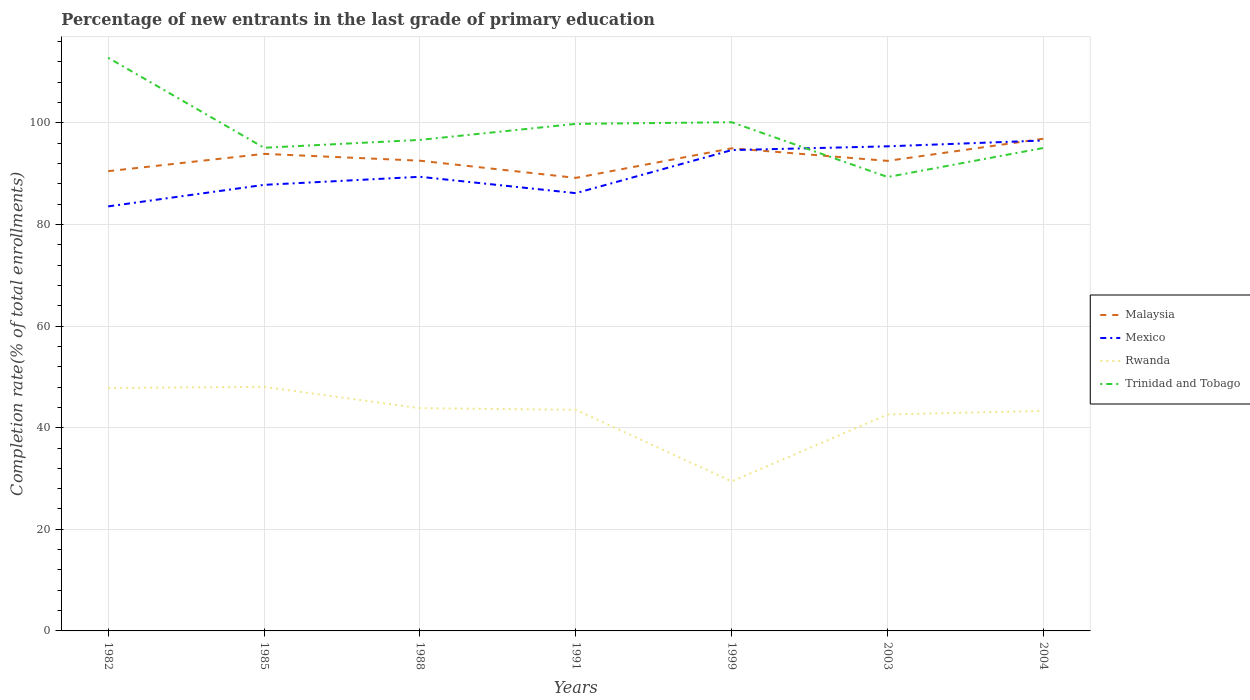How many different coloured lines are there?
Your answer should be very brief. 4. Is the number of lines equal to the number of legend labels?
Your answer should be compact. Yes. Across all years, what is the maximum percentage of new entrants in Trinidad and Tobago?
Your answer should be very brief. 89.33. In which year was the percentage of new entrants in Mexico maximum?
Your answer should be compact. 1982. What is the total percentage of new entrants in Trinidad and Tobago in the graph?
Keep it short and to the point. -1.55. What is the difference between the highest and the second highest percentage of new entrants in Mexico?
Provide a succinct answer. 12.97. How many lines are there?
Your response must be concise. 4. How many years are there in the graph?
Your response must be concise. 7. What is the difference between two consecutive major ticks on the Y-axis?
Your response must be concise. 20. How many legend labels are there?
Your response must be concise. 4. How are the legend labels stacked?
Your answer should be compact. Vertical. What is the title of the graph?
Keep it short and to the point. Percentage of new entrants in the last grade of primary education. What is the label or title of the Y-axis?
Your answer should be compact. Completion rate(% of total enrollments). What is the Completion rate(% of total enrollments) of Malaysia in 1982?
Your answer should be compact. 90.48. What is the Completion rate(% of total enrollments) of Mexico in 1982?
Your response must be concise. 83.55. What is the Completion rate(% of total enrollments) of Rwanda in 1982?
Your response must be concise. 47.82. What is the Completion rate(% of total enrollments) in Trinidad and Tobago in 1982?
Make the answer very short. 112.8. What is the Completion rate(% of total enrollments) in Malaysia in 1985?
Keep it short and to the point. 93.89. What is the Completion rate(% of total enrollments) in Mexico in 1985?
Provide a short and direct response. 87.79. What is the Completion rate(% of total enrollments) in Rwanda in 1985?
Provide a short and direct response. 48.02. What is the Completion rate(% of total enrollments) in Trinidad and Tobago in 1985?
Your answer should be compact. 95.09. What is the Completion rate(% of total enrollments) in Malaysia in 1988?
Your answer should be compact. 92.54. What is the Completion rate(% of total enrollments) in Mexico in 1988?
Provide a short and direct response. 89.37. What is the Completion rate(% of total enrollments) in Rwanda in 1988?
Your answer should be very brief. 43.84. What is the Completion rate(% of total enrollments) in Trinidad and Tobago in 1988?
Ensure brevity in your answer.  96.64. What is the Completion rate(% of total enrollments) in Malaysia in 1991?
Offer a terse response. 89.16. What is the Completion rate(% of total enrollments) of Mexico in 1991?
Give a very brief answer. 86.16. What is the Completion rate(% of total enrollments) of Rwanda in 1991?
Make the answer very short. 43.52. What is the Completion rate(% of total enrollments) of Trinidad and Tobago in 1991?
Offer a terse response. 99.79. What is the Completion rate(% of total enrollments) in Malaysia in 1999?
Your response must be concise. 94.98. What is the Completion rate(% of total enrollments) of Mexico in 1999?
Offer a terse response. 94.63. What is the Completion rate(% of total enrollments) in Rwanda in 1999?
Provide a succinct answer. 29.43. What is the Completion rate(% of total enrollments) of Trinidad and Tobago in 1999?
Offer a very short reply. 100.11. What is the Completion rate(% of total enrollments) of Malaysia in 2003?
Keep it short and to the point. 92.51. What is the Completion rate(% of total enrollments) of Mexico in 2003?
Keep it short and to the point. 95.37. What is the Completion rate(% of total enrollments) of Rwanda in 2003?
Keep it short and to the point. 42.6. What is the Completion rate(% of total enrollments) in Trinidad and Tobago in 2003?
Make the answer very short. 89.33. What is the Completion rate(% of total enrollments) in Malaysia in 2004?
Provide a short and direct response. 96.87. What is the Completion rate(% of total enrollments) in Mexico in 2004?
Offer a very short reply. 96.51. What is the Completion rate(% of total enrollments) of Rwanda in 2004?
Your response must be concise. 43.31. What is the Completion rate(% of total enrollments) in Trinidad and Tobago in 2004?
Give a very brief answer. 95.05. Across all years, what is the maximum Completion rate(% of total enrollments) in Malaysia?
Your response must be concise. 96.87. Across all years, what is the maximum Completion rate(% of total enrollments) of Mexico?
Your answer should be compact. 96.51. Across all years, what is the maximum Completion rate(% of total enrollments) in Rwanda?
Your answer should be compact. 48.02. Across all years, what is the maximum Completion rate(% of total enrollments) of Trinidad and Tobago?
Your answer should be compact. 112.8. Across all years, what is the minimum Completion rate(% of total enrollments) of Malaysia?
Give a very brief answer. 89.16. Across all years, what is the minimum Completion rate(% of total enrollments) of Mexico?
Offer a terse response. 83.55. Across all years, what is the minimum Completion rate(% of total enrollments) in Rwanda?
Your answer should be compact. 29.43. Across all years, what is the minimum Completion rate(% of total enrollments) in Trinidad and Tobago?
Provide a succinct answer. 89.33. What is the total Completion rate(% of total enrollments) in Malaysia in the graph?
Your response must be concise. 650.44. What is the total Completion rate(% of total enrollments) of Mexico in the graph?
Provide a short and direct response. 633.38. What is the total Completion rate(% of total enrollments) of Rwanda in the graph?
Your response must be concise. 298.53. What is the total Completion rate(% of total enrollments) in Trinidad and Tobago in the graph?
Ensure brevity in your answer.  688.81. What is the difference between the Completion rate(% of total enrollments) of Malaysia in 1982 and that in 1985?
Your answer should be compact. -3.41. What is the difference between the Completion rate(% of total enrollments) in Mexico in 1982 and that in 1985?
Your answer should be very brief. -4.24. What is the difference between the Completion rate(% of total enrollments) in Rwanda in 1982 and that in 1985?
Provide a succinct answer. -0.2. What is the difference between the Completion rate(% of total enrollments) in Trinidad and Tobago in 1982 and that in 1985?
Offer a terse response. 17.72. What is the difference between the Completion rate(% of total enrollments) of Malaysia in 1982 and that in 1988?
Give a very brief answer. -2.06. What is the difference between the Completion rate(% of total enrollments) in Mexico in 1982 and that in 1988?
Offer a terse response. -5.83. What is the difference between the Completion rate(% of total enrollments) in Rwanda in 1982 and that in 1988?
Make the answer very short. 3.98. What is the difference between the Completion rate(% of total enrollments) of Trinidad and Tobago in 1982 and that in 1988?
Your answer should be compact. 16.16. What is the difference between the Completion rate(% of total enrollments) in Malaysia in 1982 and that in 1991?
Keep it short and to the point. 1.32. What is the difference between the Completion rate(% of total enrollments) of Mexico in 1982 and that in 1991?
Provide a short and direct response. -2.61. What is the difference between the Completion rate(% of total enrollments) in Rwanda in 1982 and that in 1991?
Give a very brief answer. 4.3. What is the difference between the Completion rate(% of total enrollments) of Trinidad and Tobago in 1982 and that in 1991?
Provide a short and direct response. 13.01. What is the difference between the Completion rate(% of total enrollments) of Malaysia in 1982 and that in 1999?
Give a very brief answer. -4.5. What is the difference between the Completion rate(% of total enrollments) of Mexico in 1982 and that in 1999?
Provide a succinct answer. -11.08. What is the difference between the Completion rate(% of total enrollments) of Rwanda in 1982 and that in 1999?
Keep it short and to the point. 18.39. What is the difference between the Completion rate(% of total enrollments) of Trinidad and Tobago in 1982 and that in 1999?
Keep it short and to the point. 12.69. What is the difference between the Completion rate(% of total enrollments) of Malaysia in 1982 and that in 2003?
Make the answer very short. -2.02. What is the difference between the Completion rate(% of total enrollments) in Mexico in 1982 and that in 2003?
Ensure brevity in your answer.  -11.82. What is the difference between the Completion rate(% of total enrollments) in Rwanda in 1982 and that in 2003?
Your response must be concise. 5.22. What is the difference between the Completion rate(% of total enrollments) of Trinidad and Tobago in 1982 and that in 2003?
Make the answer very short. 23.47. What is the difference between the Completion rate(% of total enrollments) in Malaysia in 1982 and that in 2004?
Keep it short and to the point. -6.39. What is the difference between the Completion rate(% of total enrollments) in Mexico in 1982 and that in 2004?
Your answer should be very brief. -12.97. What is the difference between the Completion rate(% of total enrollments) of Rwanda in 1982 and that in 2004?
Provide a short and direct response. 4.51. What is the difference between the Completion rate(% of total enrollments) in Trinidad and Tobago in 1982 and that in 2004?
Your answer should be compact. 17.76. What is the difference between the Completion rate(% of total enrollments) of Malaysia in 1985 and that in 1988?
Offer a terse response. 1.34. What is the difference between the Completion rate(% of total enrollments) in Mexico in 1985 and that in 1988?
Ensure brevity in your answer.  -1.59. What is the difference between the Completion rate(% of total enrollments) in Rwanda in 1985 and that in 1988?
Give a very brief answer. 4.19. What is the difference between the Completion rate(% of total enrollments) in Trinidad and Tobago in 1985 and that in 1988?
Your answer should be very brief. -1.55. What is the difference between the Completion rate(% of total enrollments) in Malaysia in 1985 and that in 1991?
Offer a very short reply. 4.73. What is the difference between the Completion rate(% of total enrollments) in Mexico in 1985 and that in 1991?
Your answer should be very brief. 1.63. What is the difference between the Completion rate(% of total enrollments) of Rwanda in 1985 and that in 1991?
Keep it short and to the point. 4.5. What is the difference between the Completion rate(% of total enrollments) of Trinidad and Tobago in 1985 and that in 1991?
Provide a short and direct response. -4.7. What is the difference between the Completion rate(% of total enrollments) in Malaysia in 1985 and that in 1999?
Offer a very short reply. -1.09. What is the difference between the Completion rate(% of total enrollments) of Mexico in 1985 and that in 1999?
Keep it short and to the point. -6.84. What is the difference between the Completion rate(% of total enrollments) of Rwanda in 1985 and that in 1999?
Keep it short and to the point. 18.6. What is the difference between the Completion rate(% of total enrollments) in Trinidad and Tobago in 1985 and that in 1999?
Ensure brevity in your answer.  -5.03. What is the difference between the Completion rate(% of total enrollments) of Malaysia in 1985 and that in 2003?
Provide a short and direct response. 1.38. What is the difference between the Completion rate(% of total enrollments) in Mexico in 1985 and that in 2003?
Your response must be concise. -7.58. What is the difference between the Completion rate(% of total enrollments) in Rwanda in 1985 and that in 2003?
Your answer should be very brief. 5.43. What is the difference between the Completion rate(% of total enrollments) in Trinidad and Tobago in 1985 and that in 2003?
Offer a terse response. 5.75. What is the difference between the Completion rate(% of total enrollments) of Malaysia in 1985 and that in 2004?
Your answer should be very brief. -2.98. What is the difference between the Completion rate(% of total enrollments) in Mexico in 1985 and that in 2004?
Offer a terse response. -8.73. What is the difference between the Completion rate(% of total enrollments) in Rwanda in 1985 and that in 2004?
Your answer should be compact. 4.72. What is the difference between the Completion rate(% of total enrollments) of Trinidad and Tobago in 1985 and that in 2004?
Your answer should be compact. 0.04. What is the difference between the Completion rate(% of total enrollments) in Malaysia in 1988 and that in 1991?
Provide a short and direct response. 3.38. What is the difference between the Completion rate(% of total enrollments) of Mexico in 1988 and that in 1991?
Your response must be concise. 3.22. What is the difference between the Completion rate(% of total enrollments) of Rwanda in 1988 and that in 1991?
Give a very brief answer. 0.32. What is the difference between the Completion rate(% of total enrollments) of Trinidad and Tobago in 1988 and that in 1991?
Offer a very short reply. -3.15. What is the difference between the Completion rate(% of total enrollments) of Malaysia in 1988 and that in 1999?
Your answer should be very brief. -2.44. What is the difference between the Completion rate(% of total enrollments) in Mexico in 1988 and that in 1999?
Give a very brief answer. -5.25. What is the difference between the Completion rate(% of total enrollments) of Rwanda in 1988 and that in 1999?
Provide a short and direct response. 14.41. What is the difference between the Completion rate(% of total enrollments) of Trinidad and Tobago in 1988 and that in 1999?
Your answer should be very brief. -3.48. What is the difference between the Completion rate(% of total enrollments) in Malaysia in 1988 and that in 2003?
Your answer should be compact. 0.04. What is the difference between the Completion rate(% of total enrollments) in Mexico in 1988 and that in 2003?
Provide a short and direct response. -6. What is the difference between the Completion rate(% of total enrollments) in Rwanda in 1988 and that in 2003?
Your answer should be very brief. 1.24. What is the difference between the Completion rate(% of total enrollments) of Trinidad and Tobago in 1988 and that in 2003?
Provide a short and direct response. 7.31. What is the difference between the Completion rate(% of total enrollments) in Malaysia in 1988 and that in 2004?
Provide a succinct answer. -4.33. What is the difference between the Completion rate(% of total enrollments) of Mexico in 1988 and that in 2004?
Your response must be concise. -7.14. What is the difference between the Completion rate(% of total enrollments) in Rwanda in 1988 and that in 2004?
Keep it short and to the point. 0.53. What is the difference between the Completion rate(% of total enrollments) of Trinidad and Tobago in 1988 and that in 2004?
Provide a succinct answer. 1.59. What is the difference between the Completion rate(% of total enrollments) of Malaysia in 1991 and that in 1999?
Offer a very short reply. -5.82. What is the difference between the Completion rate(% of total enrollments) in Mexico in 1991 and that in 1999?
Offer a terse response. -8.47. What is the difference between the Completion rate(% of total enrollments) of Rwanda in 1991 and that in 1999?
Your answer should be very brief. 14.09. What is the difference between the Completion rate(% of total enrollments) of Trinidad and Tobago in 1991 and that in 1999?
Your answer should be compact. -0.32. What is the difference between the Completion rate(% of total enrollments) in Malaysia in 1991 and that in 2003?
Your response must be concise. -3.34. What is the difference between the Completion rate(% of total enrollments) in Mexico in 1991 and that in 2003?
Keep it short and to the point. -9.22. What is the difference between the Completion rate(% of total enrollments) of Rwanda in 1991 and that in 2003?
Keep it short and to the point. 0.92. What is the difference between the Completion rate(% of total enrollments) of Trinidad and Tobago in 1991 and that in 2003?
Your response must be concise. 10.46. What is the difference between the Completion rate(% of total enrollments) in Malaysia in 1991 and that in 2004?
Make the answer very short. -7.71. What is the difference between the Completion rate(% of total enrollments) in Mexico in 1991 and that in 2004?
Ensure brevity in your answer.  -10.36. What is the difference between the Completion rate(% of total enrollments) in Rwanda in 1991 and that in 2004?
Make the answer very short. 0.21. What is the difference between the Completion rate(% of total enrollments) of Trinidad and Tobago in 1991 and that in 2004?
Your response must be concise. 4.74. What is the difference between the Completion rate(% of total enrollments) of Malaysia in 1999 and that in 2003?
Keep it short and to the point. 2.47. What is the difference between the Completion rate(% of total enrollments) in Mexico in 1999 and that in 2003?
Your answer should be very brief. -0.75. What is the difference between the Completion rate(% of total enrollments) of Rwanda in 1999 and that in 2003?
Provide a succinct answer. -13.17. What is the difference between the Completion rate(% of total enrollments) of Trinidad and Tobago in 1999 and that in 2003?
Your response must be concise. 10.78. What is the difference between the Completion rate(% of total enrollments) in Malaysia in 1999 and that in 2004?
Make the answer very short. -1.89. What is the difference between the Completion rate(% of total enrollments) of Mexico in 1999 and that in 2004?
Offer a very short reply. -1.89. What is the difference between the Completion rate(% of total enrollments) of Rwanda in 1999 and that in 2004?
Your answer should be very brief. -13.88. What is the difference between the Completion rate(% of total enrollments) in Trinidad and Tobago in 1999 and that in 2004?
Ensure brevity in your answer.  5.07. What is the difference between the Completion rate(% of total enrollments) of Malaysia in 2003 and that in 2004?
Provide a short and direct response. -4.36. What is the difference between the Completion rate(% of total enrollments) of Mexico in 2003 and that in 2004?
Keep it short and to the point. -1.14. What is the difference between the Completion rate(% of total enrollments) of Rwanda in 2003 and that in 2004?
Your answer should be very brief. -0.71. What is the difference between the Completion rate(% of total enrollments) of Trinidad and Tobago in 2003 and that in 2004?
Your answer should be very brief. -5.71. What is the difference between the Completion rate(% of total enrollments) of Malaysia in 1982 and the Completion rate(% of total enrollments) of Mexico in 1985?
Offer a terse response. 2.69. What is the difference between the Completion rate(% of total enrollments) in Malaysia in 1982 and the Completion rate(% of total enrollments) in Rwanda in 1985?
Your answer should be very brief. 42.46. What is the difference between the Completion rate(% of total enrollments) of Malaysia in 1982 and the Completion rate(% of total enrollments) of Trinidad and Tobago in 1985?
Your answer should be compact. -4.6. What is the difference between the Completion rate(% of total enrollments) in Mexico in 1982 and the Completion rate(% of total enrollments) in Rwanda in 1985?
Provide a succinct answer. 35.53. What is the difference between the Completion rate(% of total enrollments) of Mexico in 1982 and the Completion rate(% of total enrollments) of Trinidad and Tobago in 1985?
Give a very brief answer. -11.54. What is the difference between the Completion rate(% of total enrollments) in Rwanda in 1982 and the Completion rate(% of total enrollments) in Trinidad and Tobago in 1985?
Your answer should be compact. -47.27. What is the difference between the Completion rate(% of total enrollments) in Malaysia in 1982 and the Completion rate(% of total enrollments) in Mexico in 1988?
Offer a very short reply. 1.11. What is the difference between the Completion rate(% of total enrollments) in Malaysia in 1982 and the Completion rate(% of total enrollments) in Rwanda in 1988?
Make the answer very short. 46.64. What is the difference between the Completion rate(% of total enrollments) of Malaysia in 1982 and the Completion rate(% of total enrollments) of Trinidad and Tobago in 1988?
Ensure brevity in your answer.  -6.16. What is the difference between the Completion rate(% of total enrollments) in Mexico in 1982 and the Completion rate(% of total enrollments) in Rwanda in 1988?
Give a very brief answer. 39.71. What is the difference between the Completion rate(% of total enrollments) of Mexico in 1982 and the Completion rate(% of total enrollments) of Trinidad and Tobago in 1988?
Give a very brief answer. -13.09. What is the difference between the Completion rate(% of total enrollments) of Rwanda in 1982 and the Completion rate(% of total enrollments) of Trinidad and Tobago in 1988?
Provide a short and direct response. -48.82. What is the difference between the Completion rate(% of total enrollments) of Malaysia in 1982 and the Completion rate(% of total enrollments) of Mexico in 1991?
Ensure brevity in your answer.  4.33. What is the difference between the Completion rate(% of total enrollments) in Malaysia in 1982 and the Completion rate(% of total enrollments) in Rwanda in 1991?
Provide a succinct answer. 46.96. What is the difference between the Completion rate(% of total enrollments) of Malaysia in 1982 and the Completion rate(% of total enrollments) of Trinidad and Tobago in 1991?
Your answer should be very brief. -9.31. What is the difference between the Completion rate(% of total enrollments) in Mexico in 1982 and the Completion rate(% of total enrollments) in Rwanda in 1991?
Your answer should be compact. 40.03. What is the difference between the Completion rate(% of total enrollments) in Mexico in 1982 and the Completion rate(% of total enrollments) in Trinidad and Tobago in 1991?
Your response must be concise. -16.24. What is the difference between the Completion rate(% of total enrollments) of Rwanda in 1982 and the Completion rate(% of total enrollments) of Trinidad and Tobago in 1991?
Make the answer very short. -51.97. What is the difference between the Completion rate(% of total enrollments) in Malaysia in 1982 and the Completion rate(% of total enrollments) in Mexico in 1999?
Make the answer very short. -4.15. What is the difference between the Completion rate(% of total enrollments) in Malaysia in 1982 and the Completion rate(% of total enrollments) in Rwanda in 1999?
Offer a very short reply. 61.06. What is the difference between the Completion rate(% of total enrollments) in Malaysia in 1982 and the Completion rate(% of total enrollments) in Trinidad and Tobago in 1999?
Your response must be concise. -9.63. What is the difference between the Completion rate(% of total enrollments) of Mexico in 1982 and the Completion rate(% of total enrollments) of Rwanda in 1999?
Your answer should be very brief. 54.12. What is the difference between the Completion rate(% of total enrollments) of Mexico in 1982 and the Completion rate(% of total enrollments) of Trinidad and Tobago in 1999?
Make the answer very short. -16.56. What is the difference between the Completion rate(% of total enrollments) in Rwanda in 1982 and the Completion rate(% of total enrollments) in Trinidad and Tobago in 1999?
Make the answer very short. -52.29. What is the difference between the Completion rate(% of total enrollments) in Malaysia in 1982 and the Completion rate(% of total enrollments) in Mexico in 2003?
Your response must be concise. -4.89. What is the difference between the Completion rate(% of total enrollments) of Malaysia in 1982 and the Completion rate(% of total enrollments) of Rwanda in 2003?
Keep it short and to the point. 47.89. What is the difference between the Completion rate(% of total enrollments) in Malaysia in 1982 and the Completion rate(% of total enrollments) in Trinidad and Tobago in 2003?
Keep it short and to the point. 1.15. What is the difference between the Completion rate(% of total enrollments) in Mexico in 1982 and the Completion rate(% of total enrollments) in Rwanda in 2003?
Offer a terse response. 40.95. What is the difference between the Completion rate(% of total enrollments) in Mexico in 1982 and the Completion rate(% of total enrollments) in Trinidad and Tobago in 2003?
Offer a terse response. -5.78. What is the difference between the Completion rate(% of total enrollments) of Rwanda in 1982 and the Completion rate(% of total enrollments) of Trinidad and Tobago in 2003?
Ensure brevity in your answer.  -41.51. What is the difference between the Completion rate(% of total enrollments) of Malaysia in 1982 and the Completion rate(% of total enrollments) of Mexico in 2004?
Ensure brevity in your answer.  -6.03. What is the difference between the Completion rate(% of total enrollments) of Malaysia in 1982 and the Completion rate(% of total enrollments) of Rwanda in 2004?
Offer a terse response. 47.17. What is the difference between the Completion rate(% of total enrollments) in Malaysia in 1982 and the Completion rate(% of total enrollments) in Trinidad and Tobago in 2004?
Your answer should be very brief. -4.56. What is the difference between the Completion rate(% of total enrollments) in Mexico in 1982 and the Completion rate(% of total enrollments) in Rwanda in 2004?
Ensure brevity in your answer.  40.24. What is the difference between the Completion rate(% of total enrollments) of Mexico in 1982 and the Completion rate(% of total enrollments) of Trinidad and Tobago in 2004?
Provide a short and direct response. -11.5. What is the difference between the Completion rate(% of total enrollments) of Rwanda in 1982 and the Completion rate(% of total enrollments) of Trinidad and Tobago in 2004?
Ensure brevity in your answer.  -47.23. What is the difference between the Completion rate(% of total enrollments) in Malaysia in 1985 and the Completion rate(% of total enrollments) in Mexico in 1988?
Ensure brevity in your answer.  4.51. What is the difference between the Completion rate(% of total enrollments) of Malaysia in 1985 and the Completion rate(% of total enrollments) of Rwanda in 1988?
Your answer should be very brief. 50.05. What is the difference between the Completion rate(% of total enrollments) of Malaysia in 1985 and the Completion rate(% of total enrollments) of Trinidad and Tobago in 1988?
Offer a terse response. -2.75. What is the difference between the Completion rate(% of total enrollments) of Mexico in 1985 and the Completion rate(% of total enrollments) of Rwanda in 1988?
Ensure brevity in your answer.  43.95. What is the difference between the Completion rate(% of total enrollments) of Mexico in 1985 and the Completion rate(% of total enrollments) of Trinidad and Tobago in 1988?
Make the answer very short. -8.85. What is the difference between the Completion rate(% of total enrollments) in Rwanda in 1985 and the Completion rate(% of total enrollments) in Trinidad and Tobago in 1988?
Offer a very short reply. -48.61. What is the difference between the Completion rate(% of total enrollments) of Malaysia in 1985 and the Completion rate(% of total enrollments) of Mexico in 1991?
Provide a short and direct response. 7.73. What is the difference between the Completion rate(% of total enrollments) of Malaysia in 1985 and the Completion rate(% of total enrollments) of Rwanda in 1991?
Your answer should be very brief. 50.37. What is the difference between the Completion rate(% of total enrollments) of Malaysia in 1985 and the Completion rate(% of total enrollments) of Trinidad and Tobago in 1991?
Give a very brief answer. -5.9. What is the difference between the Completion rate(% of total enrollments) of Mexico in 1985 and the Completion rate(% of total enrollments) of Rwanda in 1991?
Your answer should be compact. 44.27. What is the difference between the Completion rate(% of total enrollments) in Mexico in 1985 and the Completion rate(% of total enrollments) in Trinidad and Tobago in 1991?
Make the answer very short. -12. What is the difference between the Completion rate(% of total enrollments) of Rwanda in 1985 and the Completion rate(% of total enrollments) of Trinidad and Tobago in 1991?
Offer a very short reply. -51.77. What is the difference between the Completion rate(% of total enrollments) in Malaysia in 1985 and the Completion rate(% of total enrollments) in Mexico in 1999?
Your answer should be very brief. -0.74. What is the difference between the Completion rate(% of total enrollments) in Malaysia in 1985 and the Completion rate(% of total enrollments) in Rwanda in 1999?
Ensure brevity in your answer.  64.46. What is the difference between the Completion rate(% of total enrollments) of Malaysia in 1985 and the Completion rate(% of total enrollments) of Trinidad and Tobago in 1999?
Your response must be concise. -6.23. What is the difference between the Completion rate(% of total enrollments) in Mexico in 1985 and the Completion rate(% of total enrollments) in Rwanda in 1999?
Offer a very short reply. 58.36. What is the difference between the Completion rate(% of total enrollments) in Mexico in 1985 and the Completion rate(% of total enrollments) in Trinidad and Tobago in 1999?
Provide a succinct answer. -12.33. What is the difference between the Completion rate(% of total enrollments) in Rwanda in 1985 and the Completion rate(% of total enrollments) in Trinidad and Tobago in 1999?
Provide a succinct answer. -52.09. What is the difference between the Completion rate(% of total enrollments) in Malaysia in 1985 and the Completion rate(% of total enrollments) in Mexico in 2003?
Make the answer very short. -1.48. What is the difference between the Completion rate(% of total enrollments) in Malaysia in 1985 and the Completion rate(% of total enrollments) in Rwanda in 2003?
Offer a terse response. 51.29. What is the difference between the Completion rate(% of total enrollments) in Malaysia in 1985 and the Completion rate(% of total enrollments) in Trinidad and Tobago in 2003?
Your answer should be compact. 4.56. What is the difference between the Completion rate(% of total enrollments) of Mexico in 1985 and the Completion rate(% of total enrollments) of Rwanda in 2003?
Offer a terse response. 45.19. What is the difference between the Completion rate(% of total enrollments) in Mexico in 1985 and the Completion rate(% of total enrollments) in Trinidad and Tobago in 2003?
Your response must be concise. -1.54. What is the difference between the Completion rate(% of total enrollments) in Rwanda in 1985 and the Completion rate(% of total enrollments) in Trinidad and Tobago in 2003?
Make the answer very short. -41.31. What is the difference between the Completion rate(% of total enrollments) of Malaysia in 1985 and the Completion rate(% of total enrollments) of Mexico in 2004?
Keep it short and to the point. -2.63. What is the difference between the Completion rate(% of total enrollments) of Malaysia in 1985 and the Completion rate(% of total enrollments) of Rwanda in 2004?
Offer a terse response. 50.58. What is the difference between the Completion rate(% of total enrollments) of Malaysia in 1985 and the Completion rate(% of total enrollments) of Trinidad and Tobago in 2004?
Provide a short and direct response. -1.16. What is the difference between the Completion rate(% of total enrollments) in Mexico in 1985 and the Completion rate(% of total enrollments) in Rwanda in 2004?
Provide a short and direct response. 44.48. What is the difference between the Completion rate(% of total enrollments) of Mexico in 1985 and the Completion rate(% of total enrollments) of Trinidad and Tobago in 2004?
Provide a succinct answer. -7.26. What is the difference between the Completion rate(% of total enrollments) of Rwanda in 1985 and the Completion rate(% of total enrollments) of Trinidad and Tobago in 2004?
Make the answer very short. -47.02. What is the difference between the Completion rate(% of total enrollments) of Malaysia in 1988 and the Completion rate(% of total enrollments) of Mexico in 1991?
Provide a succinct answer. 6.39. What is the difference between the Completion rate(% of total enrollments) in Malaysia in 1988 and the Completion rate(% of total enrollments) in Rwanda in 1991?
Your response must be concise. 49.03. What is the difference between the Completion rate(% of total enrollments) of Malaysia in 1988 and the Completion rate(% of total enrollments) of Trinidad and Tobago in 1991?
Your response must be concise. -7.25. What is the difference between the Completion rate(% of total enrollments) of Mexico in 1988 and the Completion rate(% of total enrollments) of Rwanda in 1991?
Ensure brevity in your answer.  45.86. What is the difference between the Completion rate(% of total enrollments) in Mexico in 1988 and the Completion rate(% of total enrollments) in Trinidad and Tobago in 1991?
Your response must be concise. -10.42. What is the difference between the Completion rate(% of total enrollments) of Rwanda in 1988 and the Completion rate(% of total enrollments) of Trinidad and Tobago in 1991?
Provide a succinct answer. -55.95. What is the difference between the Completion rate(% of total enrollments) in Malaysia in 1988 and the Completion rate(% of total enrollments) in Mexico in 1999?
Your answer should be very brief. -2.08. What is the difference between the Completion rate(% of total enrollments) of Malaysia in 1988 and the Completion rate(% of total enrollments) of Rwanda in 1999?
Keep it short and to the point. 63.12. What is the difference between the Completion rate(% of total enrollments) of Malaysia in 1988 and the Completion rate(% of total enrollments) of Trinidad and Tobago in 1999?
Provide a succinct answer. -7.57. What is the difference between the Completion rate(% of total enrollments) in Mexico in 1988 and the Completion rate(% of total enrollments) in Rwanda in 1999?
Provide a succinct answer. 59.95. What is the difference between the Completion rate(% of total enrollments) of Mexico in 1988 and the Completion rate(% of total enrollments) of Trinidad and Tobago in 1999?
Your response must be concise. -10.74. What is the difference between the Completion rate(% of total enrollments) of Rwanda in 1988 and the Completion rate(% of total enrollments) of Trinidad and Tobago in 1999?
Your response must be concise. -56.28. What is the difference between the Completion rate(% of total enrollments) in Malaysia in 1988 and the Completion rate(% of total enrollments) in Mexico in 2003?
Make the answer very short. -2.83. What is the difference between the Completion rate(% of total enrollments) of Malaysia in 1988 and the Completion rate(% of total enrollments) of Rwanda in 2003?
Your response must be concise. 49.95. What is the difference between the Completion rate(% of total enrollments) of Malaysia in 1988 and the Completion rate(% of total enrollments) of Trinidad and Tobago in 2003?
Your response must be concise. 3.21. What is the difference between the Completion rate(% of total enrollments) in Mexico in 1988 and the Completion rate(% of total enrollments) in Rwanda in 2003?
Provide a short and direct response. 46.78. What is the difference between the Completion rate(% of total enrollments) in Mexico in 1988 and the Completion rate(% of total enrollments) in Trinidad and Tobago in 2003?
Make the answer very short. 0.04. What is the difference between the Completion rate(% of total enrollments) in Rwanda in 1988 and the Completion rate(% of total enrollments) in Trinidad and Tobago in 2003?
Keep it short and to the point. -45.49. What is the difference between the Completion rate(% of total enrollments) of Malaysia in 1988 and the Completion rate(% of total enrollments) of Mexico in 2004?
Ensure brevity in your answer.  -3.97. What is the difference between the Completion rate(% of total enrollments) in Malaysia in 1988 and the Completion rate(% of total enrollments) in Rwanda in 2004?
Offer a terse response. 49.24. What is the difference between the Completion rate(% of total enrollments) in Malaysia in 1988 and the Completion rate(% of total enrollments) in Trinidad and Tobago in 2004?
Provide a short and direct response. -2.5. What is the difference between the Completion rate(% of total enrollments) of Mexico in 1988 and the Completion rate(% of total enrollments) of Rwanda in 2004?
Offer a terse response. 46.07. What is the difference between the Completion rate(% of total enrollments) of Mexico in 1988 and the Completion rate(% of total enrollments) of Trinidad and Tobago in 2004?
Ensure brevity in your answer.  -5.67. What is the difference between the Completion rate(% of total enrollments) in Rwanda in 1988 and the Completion rate(% of total enrollments) in Trinidad and Tobago in 2004?
Keep it short and to the point. -51.21. What is the difference between the Completion rate(% of total enrollments) in Malaysia in 1991 and the Completion rate(% of total enrollments) in Mexico in 1999?
Provide a succinct answer. -5.46. What is the difference between the Completion rate(% of total enrollments) of Malaysia in 1991 and the Completion rate(% of total enrollments) of Rwanda in 1999?
Your answer should be very brief. 59.74. What is the difference between the Completion rate(% of total enrollments) in Malaysia in 1991 and the Completion rate(% of total enrollments) in Trinidad and Tobago in 1999?
Provide a short and direct response. -10.95. What is the difference between the Completion rate(% of total enrollments) in Mexico in 1991 and the Completion rate(% of total enrollments) in Rwanda in 1999?
Your answer should be very brief. 56.73. What is the difference between the Completion rate(% of total enrollments) of Mexico in 1991 and the Completion rate(% of total enrollments) of Trinidad and Tobago in 1999?
Make the answer very short. -13.96. What is the difference between the Completion rate(% of total enrollments) in Rwanda in 1991 and the Completion rate(% of total enrollments) in Trinidad and Tobago in 1999?
Provide a succinct answer. -56.6. What is the difference between the Completion rate(% of total enrollments) in Malaysia in 1991 and the Completion rate(% of total enrollments) in Mexico in 2003?
Your response must be concise. -6.21. What is the difference between the Completion rate(% of total enrollments) of Malaysia in 1991 and the Completion rate(% of total enrollments) of Rwanda in 2003?
Your answer should be very brief. 46.57. What is the difference between the Completion rate(% of total enrollments) of Malaysia in 1991 and the Completion rate(% of total enrollments) of Trinidad and Tobago in 2003?
Your response must be concise. -0.17. What is the difference between the Completion rate(% of total enrollments) of Mexico in 1991 and the Completion rate(% of total enrollments) of Rwanda in 2003?
Offer a terse response. 43.56. What is the difference between the Completion rate(% of total enrollments) in Mexico in 1991 and the Completion rate(% of total enrollments) in Trinidad and Tobago in 2003?
Your answer should be very brief. -3.18. What is the difference between the Completion rate(% of total enrollments) in Rwanda in 1991 and the Completion rate(% of total enrollments) in Trinidad and Tobago in 2003?
Keep it short and to the point. -45.81. What is the difference between the Completion rate(% of total enrollments) in Malaysia in 1991 and the Completion rate(% of total enrollments) in Mexico in 2004?
Make the answer very short. -7.35. What is the difference between the Completion rate(% of total enrollments) in Malaysia in 1991 and the Completion rate(% of total enrollments) in Rwanda in 2004?
Your response must be concise. 45.85. What is the difference between the Completion rate(% of total enrollments) of Malaysia in 1991 and the Completion rate(% of total enrollments) of Trinidad and Tobago in 2004?
Provide a succinct answer. -5.88. What is the difference between the Completion rate(% of total enrollments) in Mexico in 1991 and the Completion rate(% of total enrollments) in Rwanda in 2004?
Your answer should be compact. 42.85. What is the difference between the Completion rate(% of total enrollments) of Mexico in 1991 and the Completion rate(% of total enrollments) of Trinidad and Tobago in 2004?
Give a very brief answer. -8.89. What is the difference between the Completion rate(% of total enrollments) of Rwanda in 1991 and the Completion rate(% of total enrollments) of Trinidad and Tobago in 2004?
Keep it short and to the point. -51.53. What is the difference between the Completion rate(% of total enrollments) in Malaysia in 1999 and the Completion rate(% of total enrollments) in Mexico in 2003?
Your answer should be compact. -0.39. What is the difference between the Completion rate(% of total enrollments) of Malaysia in 1999 and the Completion rate(% of total enrollments) of Rwanda in 2003?
Your answer should be compact. 52.38. What is the difference between the Completion rate(% of total enrollments) of Malaysia in 1999 and the Completion rate(% of total enrollments) of Trinidad and Tobago in 2003?
Ensure brevity in your answer.  5.65. What is the difference between the Completion rate(% of total enrollments) in Mexico in 1999 and the Completion rate(% of total enrollments) in Rwanda in 2003?
Your response must be concise. 52.03. What is the difference between the Completion rate(% of total enrollments) in Mexico in 1999 and the Completion rate(% of total enrollments) in Trinidad and Tobago in 2003?
Provide a short and direct response. 5.3. What is the difference between the Completion rate(% of total enrollments) of Rwanda in 1999 and the Completion rate(% of total enrollments) of Trinidad and Tobago in 2003?
Provide a short and direct response. -59.91. What is the difference between the Completion rate(% of total enrollments) of Malaysia in 1999 and the Completion rate(% of total enrollments) of Mexico in 2004?
Ensure brevity in your answer.  -1.53. What is the difference between the Completion rate(% of total enrollments) in Malaysia in 1999 and the Completion rate(% of total enrollments) in Rwanda in 2004?
Give a very brief answer. 51.67. What is the difference between the Completion rate(% of total enrollments) of Malaysia in 1999 and the Completion rate(% of total enrollments) of Trinidad and Tobago in 2004?
Provide a short and direct response. -0.06. What is the difference between the Completion rate(% of total enrollments) in Mexico in 1999 and the Completion rate(% of total enrollments) in Rwanda in 2004?
Offer a terse response. 51.32. What is the difference between the Completion rate(% of total enrollments) of Mexico in 1999 and the Completion rate(% of total enrollments) of Trinidad and Tobago in 2004?
Ensure brevity in your answer.  -0.42. What is the difference between the Completion rate(% of total enrollments) of Rwanda in 1999 and the Completion rate(% of total enrollments) of Trinidad and Tobago in 2004?
Offer a very short reply. -65.62. What is the difference between the Completion rate(% of total enrollments) in Malaysia in 2003 and the Completion rate(% of total enrollments) in Mexico in 2004?
Offer a terse response. -4.01. What is the difference between the Completion rate(% of total enrollments) of Malaysia in 2003 and the Completion rate(% of total enrollments) of Rwanda in 2004?
Your answer should be very brief. 49.2. What is the difference between the Completion rate(% of total enrollments) in Malaysia in 2003 and the Completion rate(% of total enrollments) in Trinidad and Tobago in 2004?
Provide a succinct answer. -2.54. What is the difference between the Completion rate(% of total enrollments) in Mexico in 2003 and the Completion rate(% of total enrollments) in Rwanda in 2004?
Ensure brevity in your answer.  52.06. What is the difference between the Completion rate(% of total enrollments) in Mexico in 2003 and the Completion rate(% of total enrollments) in Trinidad and Tobago in 2004?
Give a very brief answer. 0.33. What is the difference between the Completion rate(% of total enrollments) in Rwanda in 2003 and the Completion rate(% of total enrollments) in Trinidad and Tobago in 2004?
Your answer should be very brief. -52.45. What is the average Completion rate(% of total enrollments) in Malaysia per year?
Provide a succinct answer. 92.92. What is the average Completion rate(% of total enrollments) of Mexico per year?
Your response must be concise. 90.48. What is the average Completion rate(% of total enrollments) in Rwanda per year?
Ensure brevity in your answer.  42.65. What is the average Completion rate(% of total enrollments) in Trinidad and Tobago per year?
Offer a very short reply. 98.4. In the year 1982, what is the difference between the Completion rate(% of total enrollments) in Malaysia and Completion rate(% of total enrollments) in Mexico?
Keep it short and to the point. 6.93. In the year 1982, what is the difference between the Completion rate(% of total enrollments) of Malaysia and Completion rate(% of total enrollments) of Rwanda?
Provide a succinct answer. 42.66. In the year 1982, what is the difference between the Completion rate(% of total enrollments) in Malaysia and Completion rate(% of total enrollments) in Trinidad and Tobago?
Your response must be concise. -22.32. In the year 1982, what is the difference between the Completion rate(% of total enrollments) of Mexico and Completion rate(% of total enrollments) of Rwanda?
Make the answer very short. 35.73. In the year 1982, what is the difference between the Completion rate(% of total enrollments) of Mexico and Completion rate(% of total enrollments) of Trinidad and Tobago?
Offer a terse response. -29.25. In the year 1982, what is the difference between the Completion rate(% of total enrollments) in Rwanda and Completion rate(% of total enrollments) in Trinidad and Tobago?
Your response must be concise. -64.98. In the year 1985, what is the difference between the Completion rate(% of total enrollments) in Malaysia and Completion rate(% of total enrollments) in Mexico?
Keep it short and to the point. 6.1. In the year 1985, what is the difference between the Completion rate(% of total enrollments) of Malaysia and Completion rate(% of total enrollments) of Rwanda?
Provide a short and direct response. 45.86. In the year 1985, what is the difference between the Completion rate(% of total enrollments) of Malaysia and Completion rate(% of total enrollments) of Trinidad and Tobago?
Your answer should be very brief. -1.2. In the year 1985, what is the difference between the Completion rate(% of total enrollments) of Mexico and Completion rate(% of total enrollments) of Rwanda?
Provide a succinct answer. 39.77. In the year 1985, what is the difference between the Completion rate(% of total enrollments) in Mexico and Completion rate(% of total enrollments) in Trinidad and Tobago?
Offer a very short reply. -7.3. In the year 1985, what is the difference between the Completion rate(% of total enrollments) of Rwanda and Completion rate(% of total enrollments) of Trinidad and Tobago?
Offer a terse response. -47.06. In the year 1988, what is the difference between the Completion rate(% of total enrollments) in Malaysia and Completion rate(% of total enrollments) in Mexico?
Keep it short and to the point. 3.17. In the year 1988, what is the difference between the Completion rate(% of total enrollments) of Malaysia and Completion rate(% of total enrollments) of Rwanda?
Your answer should be compact. 48.71. In the year 1988, what is the difference between the Completion rate(% of total enrollments) of Malaysia and Completion rate(% of total enrollments) of Trinidad and Tobago?
Give a very brief answer. -4.09. In the year 1988, what is the difference between the Completion rate(% of total enrollments) of Mexico and Completion rate(% of total enrollments) of Rwanda?
Your answer should be very brief. 45.54. In the year 1988, what is the difference between the Completion rate(% of total enrollments) in Mexico and Completion rate(% of total enrollments) in Trinidad and Tobago?
Your answer should be compact. -7.26. In the year 1988, what is the difference between the Completion rate(% of total enrollments) in Rwanda and Completion rate(% of total enrollments) in Trinidad and Tobago?
Give a very brief answer. -52.8. In the year 1991, what is the difference between the Completion rate(% of total enrollments) of Malaysia and Completion rate(% of total enrollments) of Mexico?
Your answer should be very brief. 3.01. In the year 1991, what is the difference between the Completion rate(% of total enrollments) of Malaysia and Completion rate(% of total enrollments) of Rwanda?
Keep it short and to the point. 45.64. In the year 1991, what is the difference between the Completion rate(% of total enrollments) in Malaysia and Completion rate(% of total enrollments) in Trinidad and Tobago?
Offer a very short reply. -10.63. In the year 1991, what is the difference between the Completion rate(% of total enrollments) in Mexico and Completion rate(% of total enrollments) in Rwanda?
Offer a very short reply. 42.64. In the year 1991, what is the difference between the Completion rate(% of total enrollments) of Mexico and Completion rate(% of total enrollments) of Trinidad and Tobago?
Your answer should be compact. -13.63. In the year 1991, what is the difference between the Completion rate(% of total enrollments) of Rwanda and Completion rate(% of total enrollments) of Trinidad and Tobago?
Give a very brief answer. -56.27. In the year 1999, what is the difference between the Completion rate(% of total enrollments) in Malaysia and Completion rate(% of total enrollments) in Mexico?
Your answer should be very brief. 0.35. In the year 1999, what is the difference between the Completion rate(% of total enrollments) of Malaysia and Completion rate(% of total enrollments) of Rwanda?
Keep it short and to the point. 65.56. In the year 1999, what is the difference between the Completion rate(% of total enrollments) of Malaysia and Completion rate(% of total enrollments) of Trinidad and Tobago?
Provide a succinct answer. -5.13. In the year 1999, what is the difference between the Completion rate(% of total enrollments) of Mexico and Completion rate(% of total enrollments) of Rwanda?
Your answer should be very brief. 65.2. In the year 1999, what is the difference between the Completion rate(% of total enrollments) in Mexico and Completion rate(% of total enrollments) in Trinidad and Tobago?
Your answer should be very brief. -5.49. In the year 1999, what is the difference between the Completion rate(% of total enrollments) in Rwanda and Completion rate(% of total enrollments) in Trinidad and Tobago?
Your response must be concise. -70.69. In the year 2003, what is the difference between the Completion rate(% of total enrollments) in Malaysia and Completion rate(% of total enrollments) in Mexico?
Provide a short and direct response. -2.87. In the year 2003, what is the difference between the Completion rate(% of total enrollments) of Malaysia and Completion rate(% of total enrollments) of Rwanda?
Your answer should be very brief. 49.91. In the year 2003, what is the difference between the Completion rate(% of total enrollments) of Malaysia and Completion rate(% of total enrollments) of Trinidad and Tobago?
Give a very brief answer. 3.18. In the year 2003, what is the difference between the Completion rate(% of total enrollments) in Mexico and Completion rate(% of total enrollments) in Rwanda?
Provide a short and direct response. 52.78. In the year 2003, what is the difference between the Completion rate(% of total enrollments) of Mexico and Completion rate(% of total enrollments) of Trinidad and Tobago?
Make the answer very short. 6.04. In the year 2003, what is the difference between the Completion rate(% of total enrollments) of Rwanda and Completion rate(% of total enrollments) of Trinidad and Tobago?
Make the answer very short. -46.73. In the year 2004, what is the difference between the Completion rate(% of total enrollments) of Malaysia and Completion rate(% of total enrollments) of Mexico?
Provide a short and direct response. 0.36. In the year 2004, what is the difference between the Completion rate(% of total enrollments) in Malaysia and Completion rate(% of total enrollments) in Rwanda?
Your answer should be very brief. 53.56. In the year 2004, what is the difference between the Completion rate(% of total enrollments) in Malaysia and Completion rate(% of total enrollments) in Trinidad and Tobago?
Make the answer very short. 1.82. In the year 2004, what is the difference between the Completion rate(% of total enrollments) of Mexico and Completion rate(% of total enrollments) of Rwanda?
Provide a succinct answer. 53.21. In the year 2004, what is the difference between the Completion rate(% of total enrollments) in Mexico and Completion rate(% of total enrollments) in Trinidad and Tobago?
Ensure brevity in your answer.  1.47. In the year 2004, what is the difference between the Completion rate(% of total enrollments) of Rwanda and Completion rate(% of total enrollments) of Trinidad and Tobago?
Your answer should be compact. -51.74. What is the ratio of the Completion rate(% of total enrollments) in Malaysia in 1982 to that in 1985?
Make the answer very short. 0.96. What is the ratio of the Completion rate(% of total enrollments) of Mexico in 1982 to that in 1985?
Provide a short and direct response. 0.95. What is the ratio of the Completion rate(% of total enrollments) of Rwanda in 1982 to that in 1985?
Make the answer very short. 1. What is the ratio of the Completion rate(% of total enrollments) in Trinidad and Tobago in 1982 to that in 1985?
Ensure brevity in your answer.  1.19. What is the ratio of the Completion rate(% of total enrollments) in Malaysia in 1982 to that in 1988?
Your response must be concise. 0.98. What is the ratio of the Completion rate(% of total enrollments) in Mexico in 1982 to that in 1988?
Provide a succinct answer. 0.93. What is the ratio of the Completion rate(% of total enrollments) of Rwanda in 1982 to that in 1988?
Make the answer very short. 1.09. What is the ratio of the Completion rate(% of total enrollments) of Trinidad and Tobago in 1982 to that in 1988?
Give a very brief answer. 1.17. What is the ratio of the Completion rate(% of total enrollments) of Malaysia in 1982 to that in 1991?
Make the answer very short. 1.01. What is the ratio of the Completion rate(% of total enrollments) of Mexico in 1982 to that in 1991?
Your answer should be very brief. 0.97. What is the ratio of the Completion rate(% of total enrollments) in Rwanda in 1982 to that in 1991?
Give a very brief answer. 1.1. What is the ratio of the Completion rate(% of total enrollments) of Trinidad and Tobago in 1982 to that in 1991?
Your answer should be compact. 1.13. What is the ratio of the Completion rate(% of total enrollments) of Malaysia in 1982 to that in 1999?
Your answer should be compact. 0.95. What is the ratio of the Completion rate(% of total enrollments) of Mexico in 1982 to that in 1999?
Give a very brief answer. 0.88. What is the ratio of the Completion rate(% of total enrollments) of Rwanda in 1982 to that in 1999?
Offer a very short reply. 1.63. What is the ratio of the Completion rate(% of total enrollments) in Trinidad and Tobago in 1982 to that in 1999?
Your response must be concise. 1.13. What is the ratio of the Completion rate(% of total enrollments) in Malaysia in 1982 to that in 2003?
Ensure brevity in your answer.  0.98. What is the ratio of the Completion rate(% of total enrollments) of Mexico in 1982 to that in 2003?
Your answer should be compact. 0.88. What is the ratio of the Completion rate(% of total enrollments) of Rwanda in 1982 to that in 2003?
Your answer should be compact. 1.12. What is the ratio of the Completion rate(% of total enrollments) of Trinidad and Tobago in 1982 to that in 2003?
Offer a very short reply. 1.26. What is the ratio of the Completion rate(% of total enrollments) of Malaysia in 1982 to that in 2004?
Your answer should be compact. 0.93. What is the ratio of the Completion rate(% of total enrollments) of Mexico in 1982 to that in 2004?
Your response must be concise. 0.87. What is the ratio of the Completion rate(% of total enrollments) in Rwanda in 1982 to that in 2004?
Offer a very short reply. 1.1. What is the ratio of the Completion rate(% of total enrollments) of Trinidad and Tobago in 1982 to that in 2004?
Provide a succinct answer. 1.19. What is the ratio of the Completion rate(% of total enrollments) of Malaysia in 1985 to that in 1988?
Ensure brevity in your answer.  1.01. What is the ratio of the Completion rate(% of total enrollments) of Mexico in 1985 to that in 1988?
Give a very brief answer. 0.98. What is the ratio of the Completion rate(% of total enrollments) of Rwanda in 1985 to that in 1988?
Your answer should be very brief. 1.1. What is the ratio of the Completion rate(% of total enrollments) of Trinidad and Tobago in 1985 to that in 1988?
Your answer should be very brief. 0.98. What is the ratio of the Completion rate(% of total enrollments) of Malaysia in 1985 to that in 1991?
Provide a short and direct response. 1.05. What is the ratio of the Completion rate(% of total enrollments) of Rwanda in 1985 to that in 1991?
Make the answer very short. 1.1. What is the ratio of the Completion rate(% of total enrollments) in Trinidad and Tobago in 1985 to that in 1991?
Provide a succinct answer. 0.95. What is the ratio of the Completion rate(% of total enrollments) in Malaysia in 1985 to that in 1999?
Offer a very short reply. 0.99. What is the ratio of the Completion rate(% of total enrollments) in Mexico in 1985 to that in 1999?
Provide a succinct answer. 0.93. What is the ratio of the Completion rate(% of total enrollments) in Rwanda in 1985 to that in 1999?
Keep it short and to the point. 1.63. What is the ratio of the Completion rate(% of total enrollments) in Trinidad and Tobago in 1985 to that in 1999?
Provide a short and direct response. 0.95. What is the ratio of the Completion rate(% of total enrollments) in Malaysia in 1985 to that in 2003?
Make the answer very short. 1.01. What is the ratio of the Completion rate(% of total enrollments) in Mexico in 1985 to that in 2003?
Your response must be concise. 0.92. What is the ratio of the Completion rate(% of total enrollments) in Rwanda in 1985 to that in 2003?
Your answer should be compact. 1.13. What is the ratio of the Completion rate(% of total enrollments) of Trinidad and Tobago in 1985 to that in 2003?
Make the answer very short. 1.06. What is the ratio of the Completion rate(% of total enrollments) in Malaysia in 1985 to that in 2004?
Your answer should be compact. 0.97. What is the ratio of the Completion rate(% of total enrollments) in Mexico in 1985 to that in 2004?
Provide a succinct answer. 0.91. What is the ratio of the Completion rate(% of total enrollments) of Rwanda in 1985 to that in 2004?
Your answer should be compact. 1.11. What is the ratio of the Completion rate(% of total enrollments) in Malaysia in 1988 to that in 1991?
Keep it short and to the point. 1.04. What is the ratio of the Completion rate(% of total enrollments) of Mexico in 1988 to that in 1991?
Offer a very short reply. 1.04. What is the ratio of the Completion rate(% of total enrollments) of Rwanda in 1988 to that in 1991?
Your answer should be very brief. 1.01. What is the ratio of the Completion rate(% of total enrollments) in Trinidad and Tobago in 1988 to that in 1991?
Offer a very short reply. 0.97. What is the ratio of the Completion rate(% of total enrollments) in Malaysia in 1988 to that in 1999?
Provide a short and direct response. 0.97. What is the ratio of the Completion rate(% of total enrollments) in Mexico in 1988 to that in 1999?
Provide a short and direct response. 0.94. What is the ratio of the Completion rate(% of total enrollments) of Rwanda in 1988 to that in 1999?
Keep it short and to the point. 1.49. What is the ratio of the Completion rate(% of total enrollments) of Trinidad and Tobago in 1988 to that in 1999?
Offer a very short reply. 0.97. What is the ratio of the Completion rate(% of total enrollments) of Malaysia in 1988 to that in 2003?
Your answer should be compact. 1. What is the ratio of the Completion rate(% of total enrollments) in Mexico in 1988 to that in 2003?
Make the answer very short. 0.94. What is the ratio of the Completion rate(% of total enrollments) of Rwanda in 1988 to that in 2003?
Ensure brevity in your answer.  1.03. What is the ratio of the Completion rate(% of total enrollments) in Trinidad and Tobago in 1988 to that in 2003?
Provide a short and direct response. 1.08. What is the ratio of the Completion rate(% of total enrollments) in Malaysia in 1988 to that in 2004?
Give a very brief answer. 0.96. What is the ratio of the Completion rate(% of total enrollments) in Mexico in 1988 to that in 2004?
Make the answer very short. 0.93. What is the ratio of the Completion rate(% of total enrollments) of Rwanda in 1988 to that in 2004?
Provide a short and direct response. 1.01. What is the ratio of the Completion rate(% of total enrollments) of Trinidad and Tobago in 1988 to that in 2004?
Offer a terse response. 1.02. What is the ratio of the Completion rate(% of total enrollments) of Malaysia in 1991 to that in 1999?
Keep it short and to the point. 0.94. What is the ratio of the Completion rate(% of total enrollments) of Mexico in 1991 to that in 1999?
Offer a terse response. 0.91. What is the ratio of the Completion rate(% of total enrollments) of Rwanda in 1991 to that in 1999?
Keep it short and to the point. 1.48. What is the ratio of the Completion rate(% of total enrollments) in Malaysia in 1991 to that in 2003?
Offer a very short reply. 0.96. What is the ratio of the Completion rate(% of total enrollments) in Mexico in 1991 to that in 2003?
Provide a short and direct response. 0.9. What is the ratio of the Completion rate(% of total enrollments) in Rwanda in 1991 to that in 2003?
Ensure brevity in your answer.  1.02. What is the ratio of the Completion rate(% of total enrollments) in Trinidad and Tobago in 1991 to that in 2003?
Make the answer very short. 1.12. What is the ratio of the Completion rate(% of total enrollments) in Malaysia in 1991 to that in 2004?
Your answer should be compact. 0.92. What is the ratio of the Completion rate(% of total enrollments) of Mexico in 1991 to that in 2004?
Ensure brevity in your answer.  0.89. What is the ratio of the Completion rate(% of total enrollments) of Rwanda in 1991 to that in 2004?
Ensure brevity in your answer.  1. What is the ratio of the Completion rate(% of total enrollments) in Trinidad and Tobago in 1991 to that in 2004?
Make the answer very short. 1.05. What is the ratio of the Completion rate(% of total enrollments) in Malaysia in 1999 to that in 2003?
Provide a succinct answer. 1.03. What is the ratio of the Completion rate(% of total enrollments) in Rwanda in 1999 to that in 2003?
Ensure brevity in your answer.  0.69. What is the ratio of the Completion rate(% of total enrollments) in Trinidad and Tobago in 1999 to that in 2003?
Offer a terse response. 1.12. What is the ratio of the Completion rate(% of total enrollments) in Malaysia in 1999 to that in 2004?
Your answer should be compact. 0.98. What is the ratio of the Completion rate(% of total enrollments) in Mexico in 1999 to that in 2004?
Make the answer very short. 0.98. What is the ratio of the Completion rate(% of total enrollments) in Rwanda in 1999 to that in 2004?
Offer a terse response. 0.68. What is the ratio of the Completion rate(% of total enrollments) in Trinidad and Tobago in 1999 to that in 2004?
Keep it short and to the point. 1.05. What is the ratio of the Completion rate(% of total enrollments) in Malaysia in 2003 to that in 2004?
Keep it short and to the point. 0.95. What is the ratio of the Completion rate(% of total enrollments) of Rwanda in 2003 to that in 2004?
Offer a terse response. 0.98. What is the ratio of the Completion rate(% of total enrollments) in Trinidad and Tobago in 2003 to that in 2004?
Your response must be concise. 0.94. What is the difference between the highest and the second highest Completion rate(% of total enrollments) in Malaysia?
Your answer should be compact. 1.89. What is the difference between the highest and the second highest Completion rate(% of total enrollments) of Mexico?
Your answer should be very brief. 1.14. What is the difference between the highest and the second highest Completion rate(% of total enrollments) of Rwanda?
Provide a succinct answer. 0.2. What is the difference between the highest and the second highest Completion rate(% of total enrollments) of Trinidad and Tobago?
Provide a short and direct response. 12.69. What is the difference between the highest and the lowest Completion rate(% of total enrollments) of Malaysia?
Your answer should be compact. 7.71. What is the difference between the highest and the lowest Completion rate(% of total enrollments) in Mexico?
Ensure brevity in your answer.  12.97. What is the difference between the highest and the lowest Completion rate(% of total enrollments) of Rwanda?
Ensure brevity in your answer.  18.6. What is the difference between the highest and the lowest Completion rate(% of total enrollments) of Trinidad and Tobago?
Ensure brevity in your answer.  23.47. 